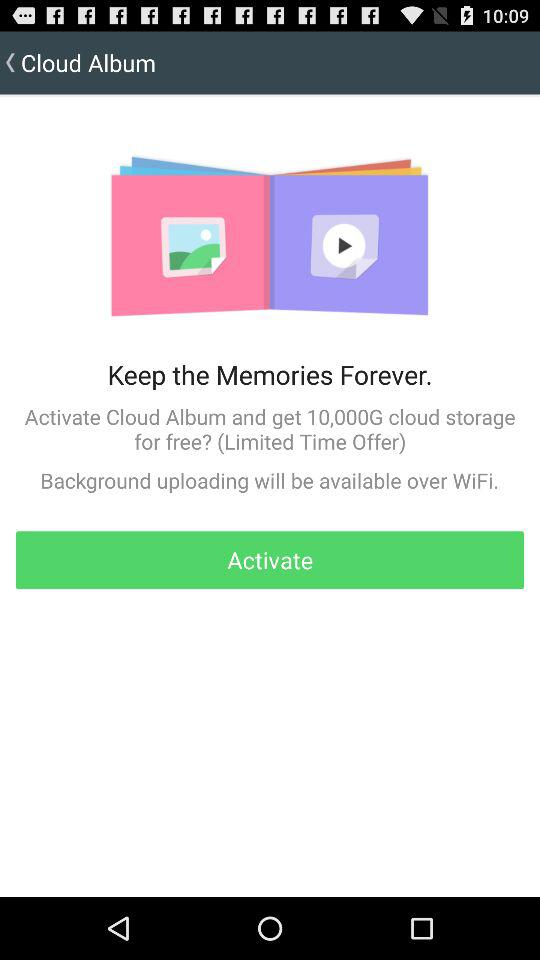How much cloud storage do we get when we activate "Cloud Album"? You get 10,000G of cloud storage when you activate "Cloud Album". 